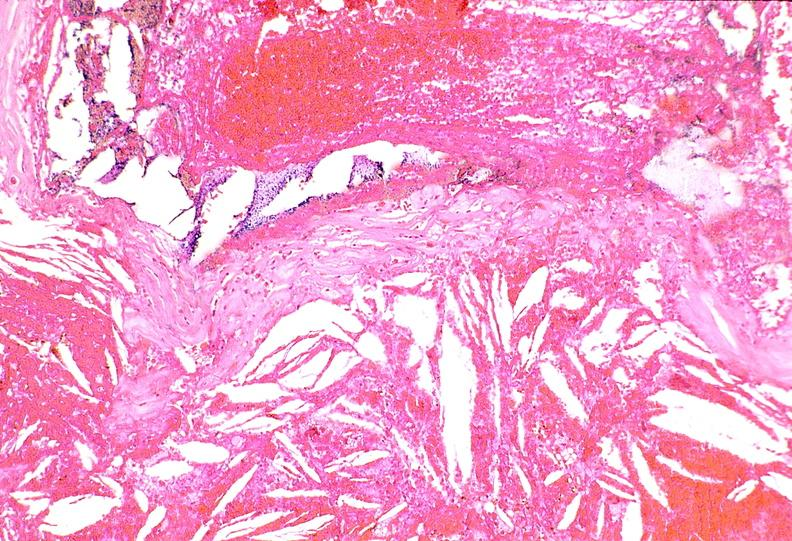does this image show right coronary artery, atherosclerosis and acute thrombus?
Answer the question using a single word or phrase. Yes 